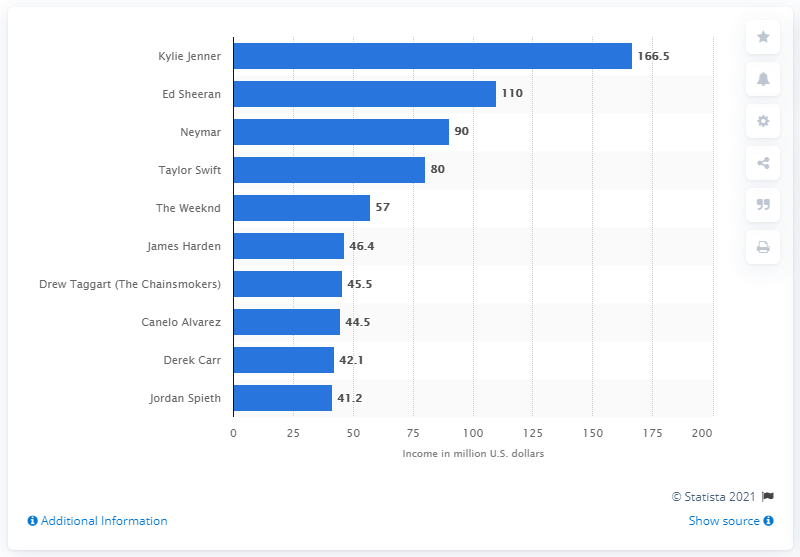Outline some significant characteristics in this image. Kylie Jenner was the highest earner between June 2017 and June 2018. Kylie Jenner's reported income over a 12-month period was 166.5. 